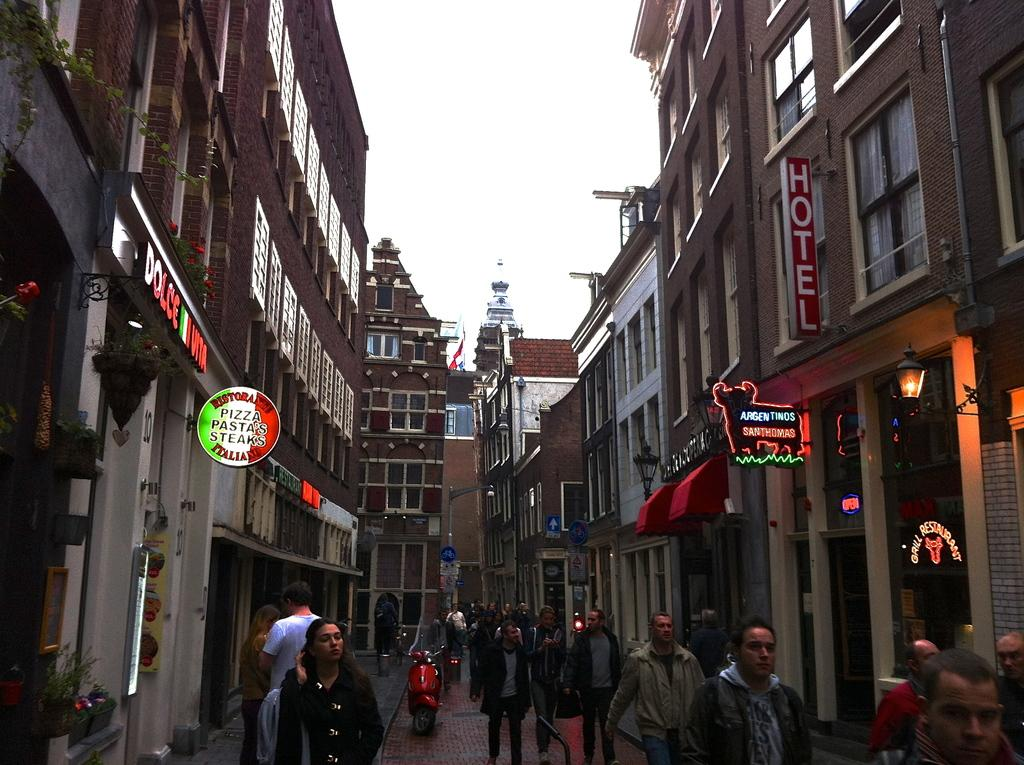What type of structures are present in the image? There are buildings in the image. Can you describe the people at the bottom of the image? There are people at the bottom of the image. What mode of transportation can be seen on the road in the image? There is a bike on the road in the image. What is visible in the background of the image? There is sky visible in the background of the image. What type of note can be seen floating in the sky in the image? There is no note visible in the sky in the image. How many boats are present in the image? There are no boats present in the image. 